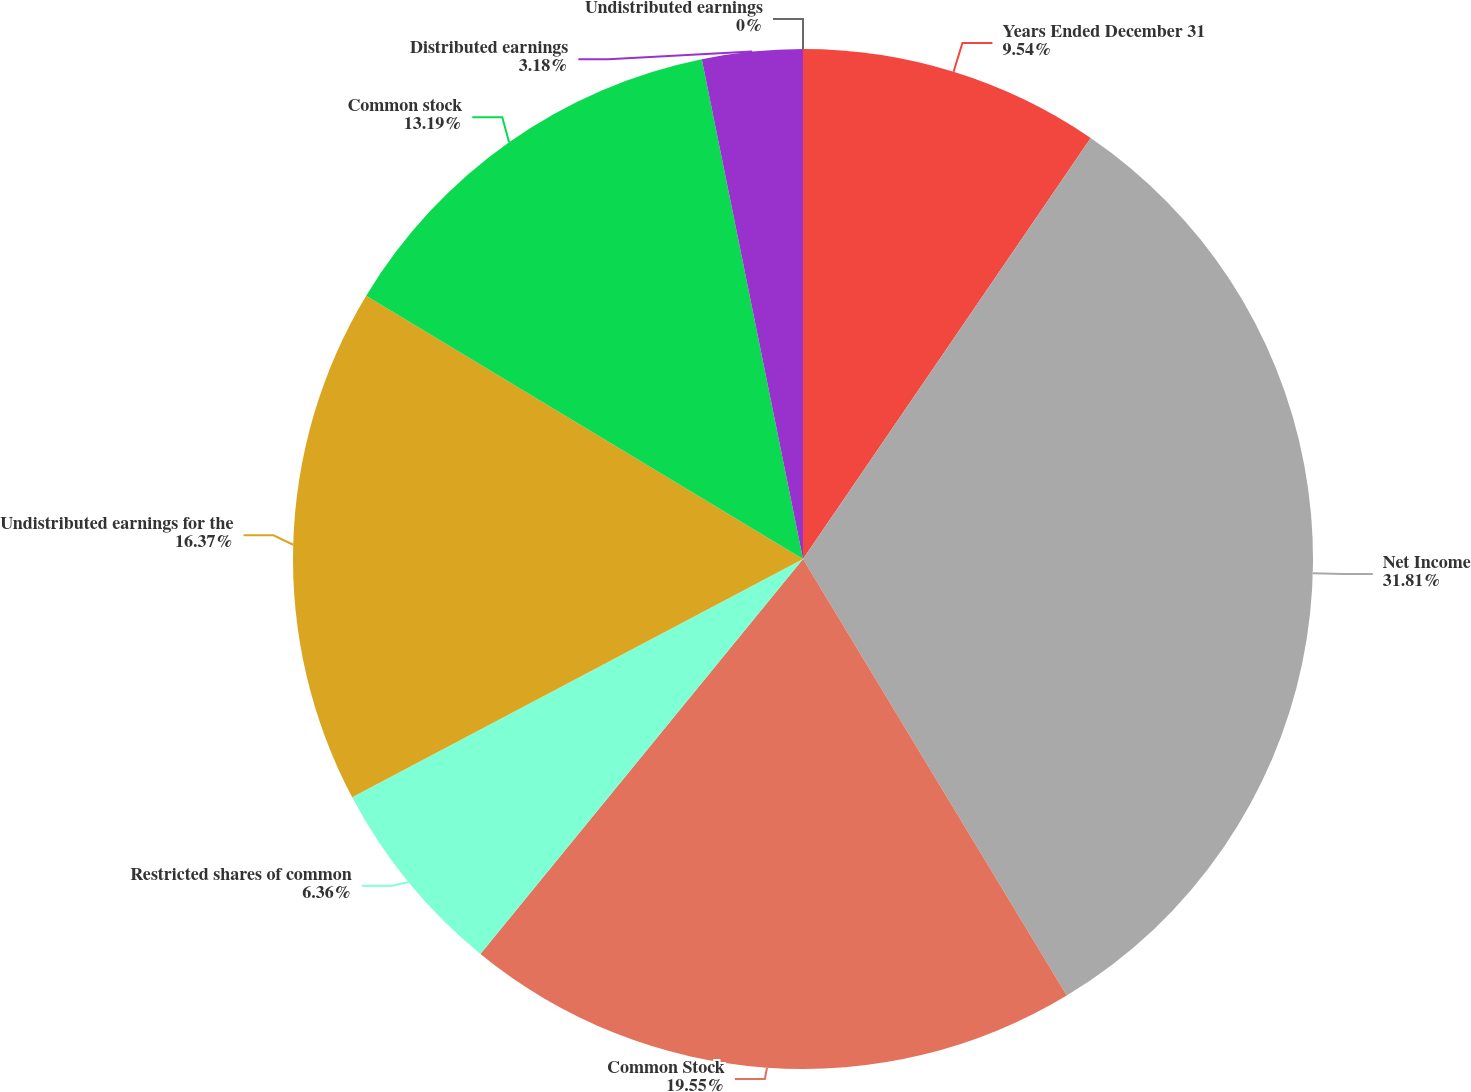<chart> <loc_0><loc_0><loc_500><loc_500><pie_chart><fcel>Years Ended December 31<fcel>Net Income<fcel>Common Stock<fcel>Restricted shares of common<fcel>Undistributed earnings for the<fcel>Common stock<fcel>Distributed earnings<fcel>Undistributed earnings<nl><fcel>9.54%<fcel>31.81%<fcel>19.55%<fcel>6.36%<fcel>16.37%<fcel>13.19%<fcel>3.18%<fcel>0.0%<nl></chart> 